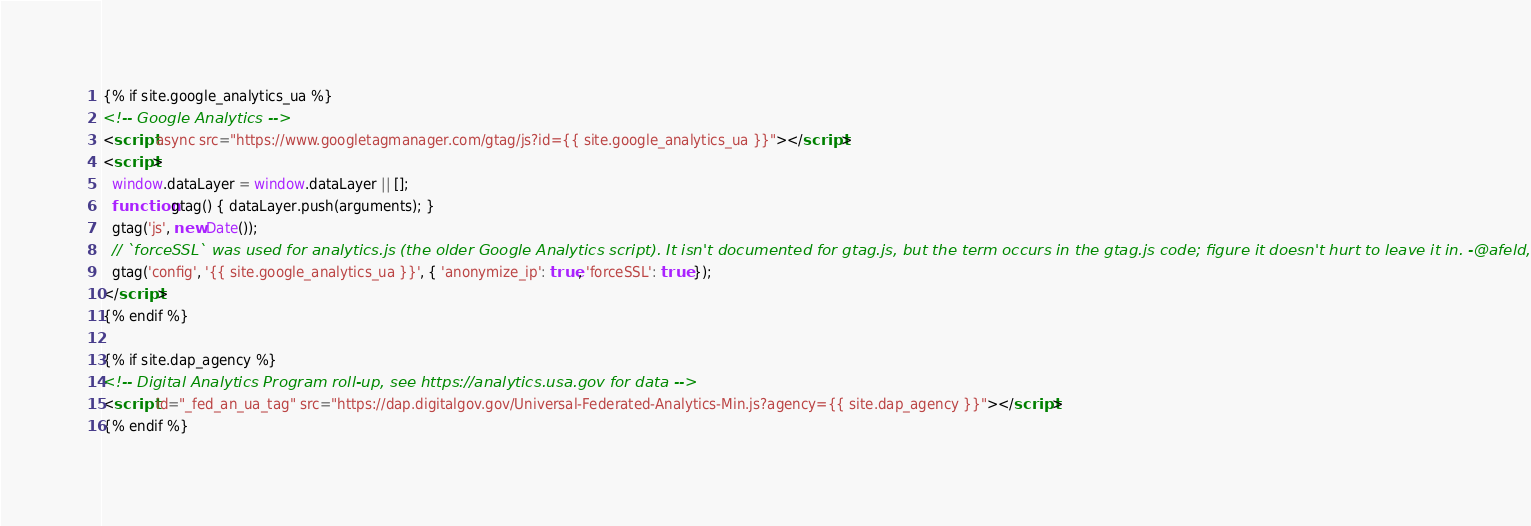Convert code to text. <code><loc_0><loc_0><loc_500><loc_500><_HTML_>{% if site.google_analytics_ua %}
<!-- Google Analytics -->
<script async src="https://www.googletagmanager.com/gtag/js?id={{ site.google_analytics_ua }}"></script>
<script>
  window.dataLayer = window.dataLayer || [];
  function gtag() { dataLayer.push(arguments); }
  gtag('js', new Date());
  // `forceSSL` was used for analytics.js (the older Google Analytics script). It isn't documented for gtag.js, but the term occurs in the gtag.js code; figure it doesn't hurt to leave it in. -@afeld, 5/29/19
  gtag('config', '{{ site.google_analytics_ua }}', { 'anonymize_ip': true, 'forceSSL': true });
</script>
{% endif %}

{% if site.dap_agency %}
<!-- Digital Analytics Program roll-up, see https://analytics.usa.gov for data -->
<script id="_fed_an_ua_tag" src="https://dap.digitalgov.gov/Universal-Federated-Analytics-Min.js?agency={{ site.dap_agency }}"></script>
{% endif %}
</code> 